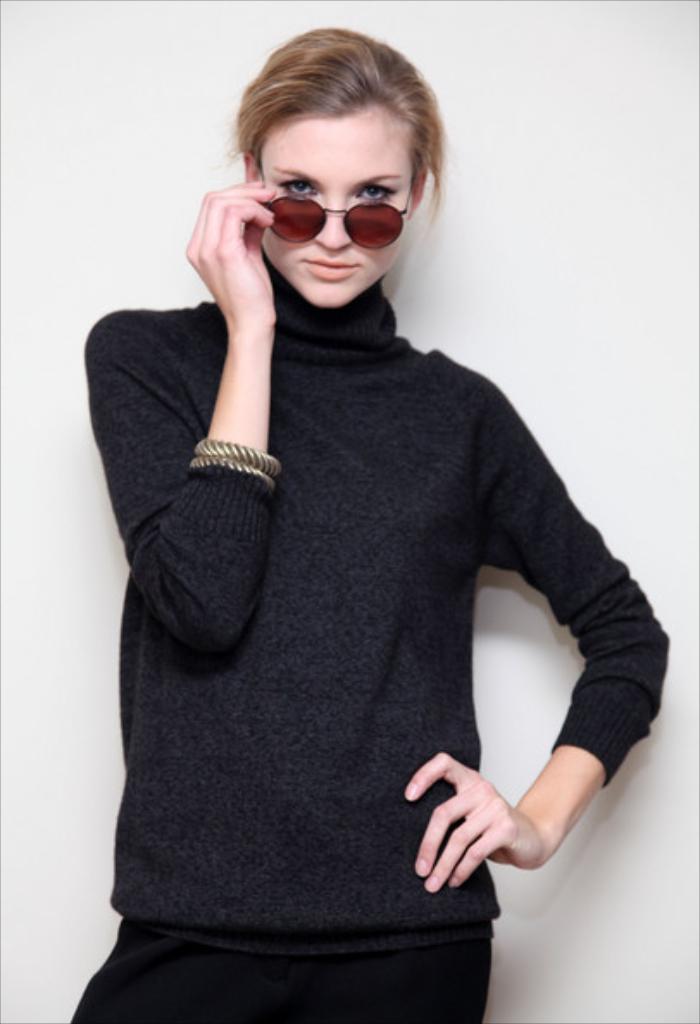Could you give a brief overview of what you see in this image? In this image I can see a woman is standing in the front. I can see she is wearing a brown shades, the black dress and two bracelets. In the background I can see the wall. 